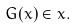Convert formula to latex. <formula><loc_0><loc_0><loc_500><loc_500>G ( x ) \in x .</formula> 